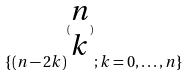Convert formula to latex. <formula><loc_0><loc_0><loc_500><loc_500>\{ ( n - 2 k ) ^ { ( \begin{matrix} n \\ k \end{matrix} ) } ; k = 0 , \dots , n \}</formula> 